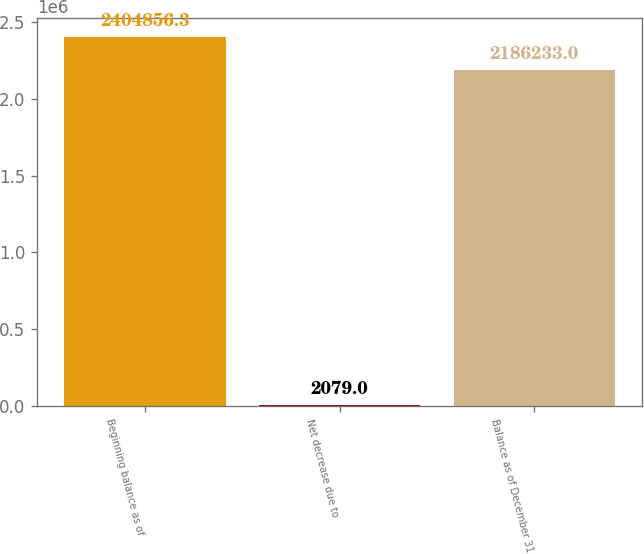Convert chart to OTSL. <chart><loc_0><loc_0><loc_500><loc_500><bar_chart><fcel>Beginning balance as of<fcel>Net decrease due to<fcel>Balance as of December 31<nl><fcel>2.40486e+06<fcel>2079<fcel>2.18623e+06<nl></chart> 